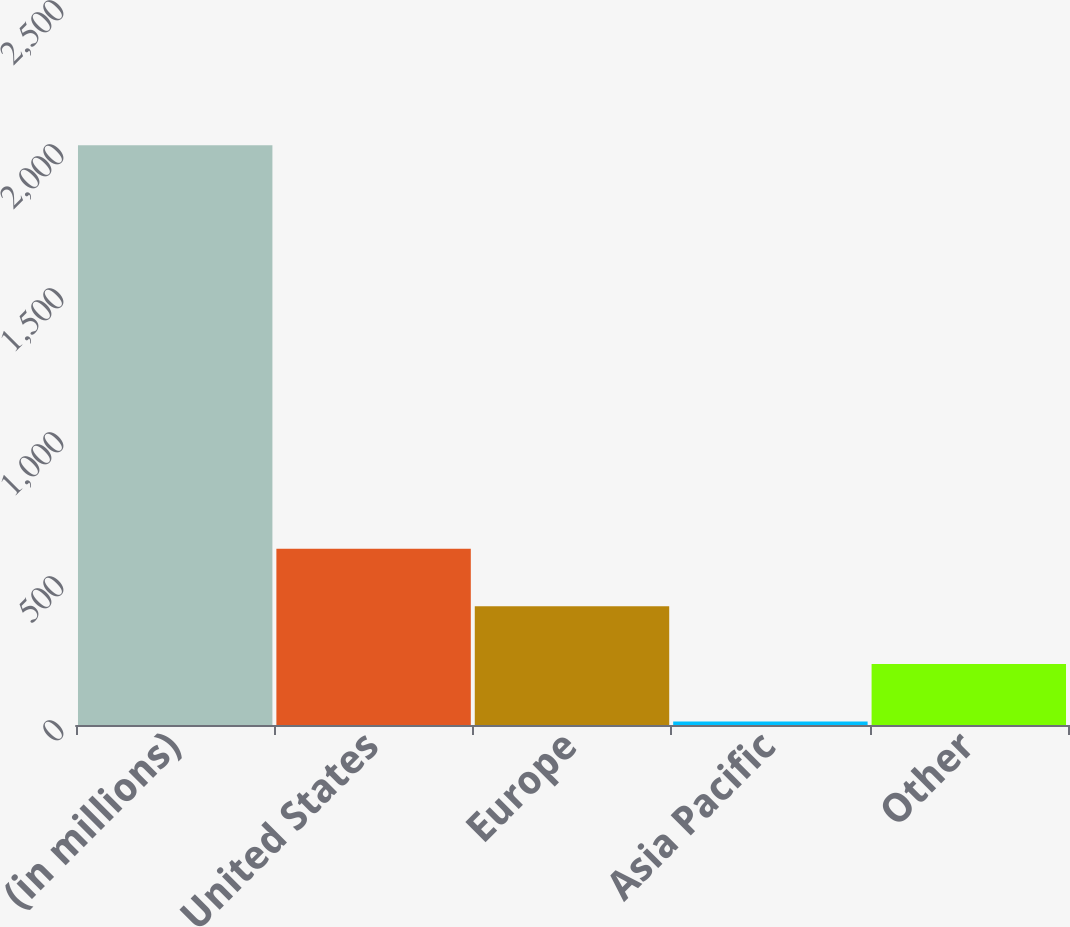<chart> <loc_0><loc_0><loc_500><loc_500><bar_chart><fcel>(in millions)<fcel>United States<fcel>Europe<fcel>Asia Pacific<fcel>Other<nl><fcel>2013<fcel>612.3<fcel>412.2<fcel>12<fcel>212.1<nl></chart> 